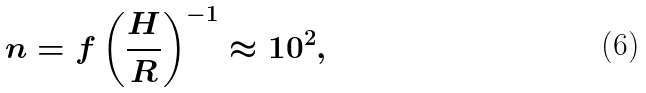Convert formula to latex. <formula><loc_0><loc_0><loc_500><loc_500>n = f \left ( \frac { H } { R } \right ) ^ { - 1 } \approx 1 0 ^ { 2 } ,</formula> 